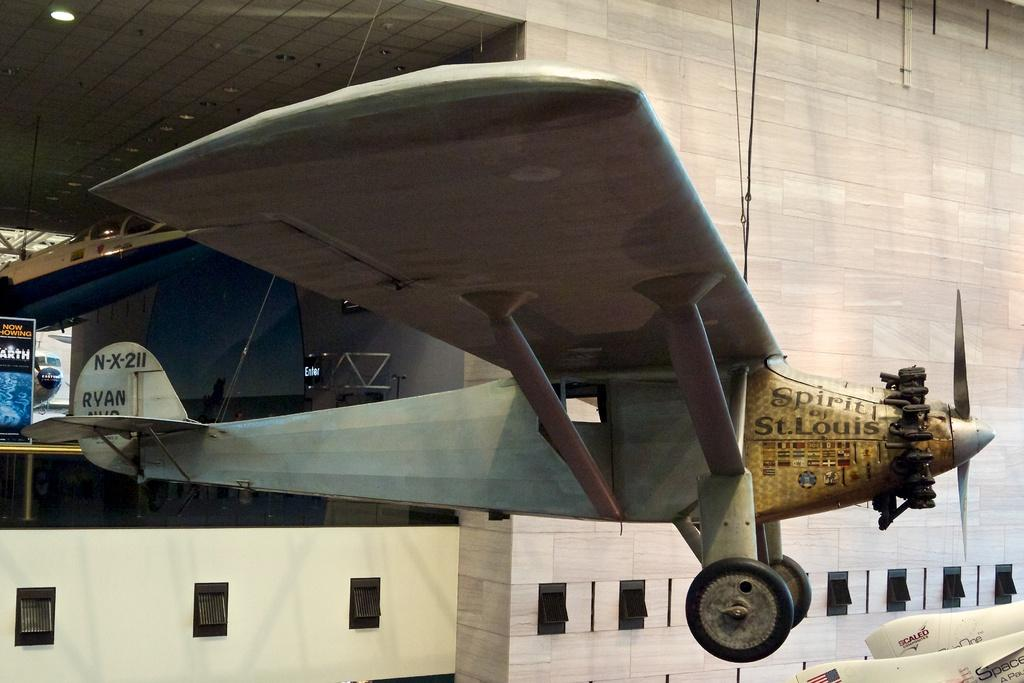<image>
Provide a brief description of the given image. An airplane displays "Spirit of St. Louis" on the right side of the nose. 